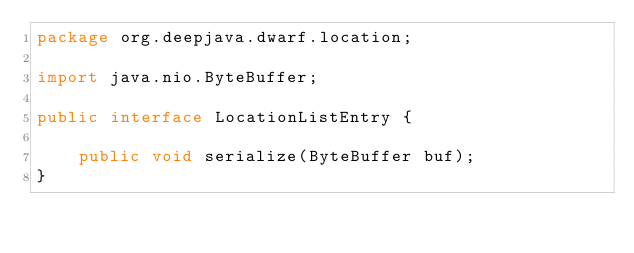<code> <loc_0><loc_0><loc_500><loc_500><_Java_>package org.deepjava.dwarf.location;

import java.nio.ByteBuffer;

public interface LocationListEntry {
	
	public void serialize(ByteBuffer buf);
}
</code> 